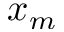<formula> <loc_0><loc_0><loc_500><loc_500>x _ { m }</formula> 